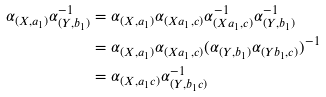Convert formula to latex. <formula><loc_0><loc_0><loc_500><loc_500>\alpha _ { ( X , a _ { 1 } ) } \alpha _ { ( Y , b _ { 1 } ) } ^ { - 1 } & = \alpha _ { ( X , a _ { 1 } ) } \alpha _ { ( X a _ { 1 } , c ) } \alpha _ { ( X a _ { 1 } , c ) } ^ { - 1 } \alpha _ { ( Y , b _ { 1 } ) } ^ { - 1 } \\ & = \alpha _ { ( X , a _ { 1 } ) } \alpha _ { ( X a _ { 1 } , c ) } ( \alpha _ { ( Y , b _ { 1 } ) } \alpha _ { ( Y b _ { 1 } , c ) } ) ^ { - 1 } \\ & = \alpha _ { ( X , a _ { 1 } c ) } \alpha _ { ( Y , b _ { 1 } c ) } ^ { - 1 }</formula> 